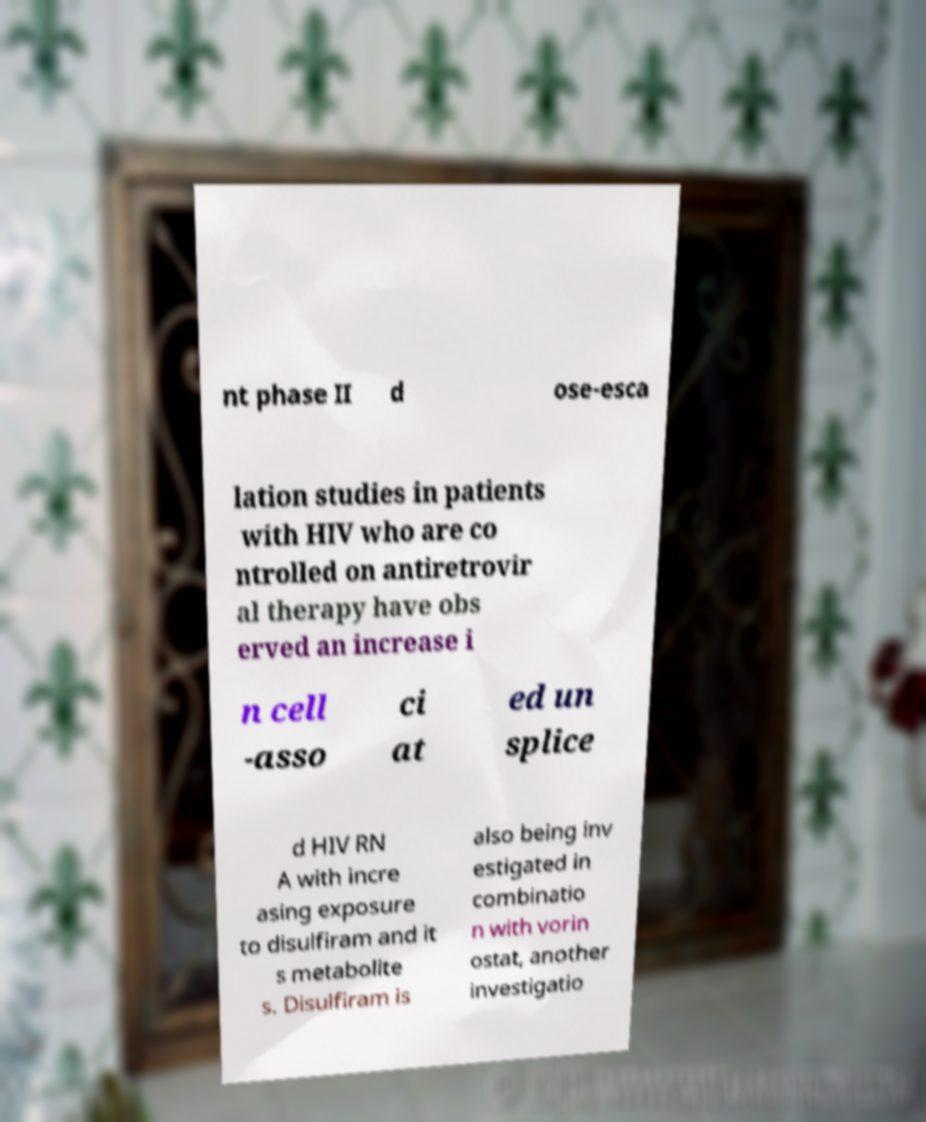Could you assist in decoding the text presented in this image and type it out clearly? nt phase II d ose-esca lation studies in patients with HIV who are co ntrolled on antiretrovir al therapy have obs erved an increase i n cell -asso ci at ed un splice d HIV RN A with incre asing exposure to disulfiram and it s metabolite s. Disulfiram is also being inv estigated in combinatio n with vorin ostat, another investigatio 